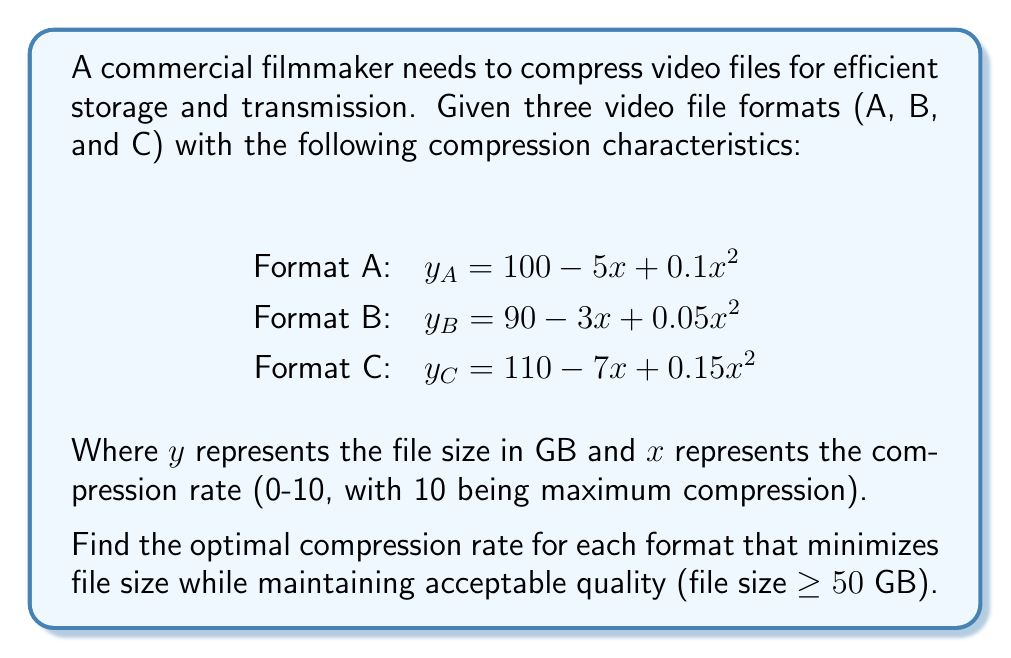Can you answer this question? To find the optimal compression rate for each format, we need to minimize $y$ (file size) while keeping it above or equal to 50 GB. We'll follow these steps for each format:

1. Find the minimum of the quadratic function by calculating its vertex.
2. Check if the minimum is above 50 GB. If not, find the point where $y = 50$.

For Format A: $y_A = 100 - 5x + 0.1x^2$

1. Vertex: $x = -b/(2a) = 5/(2(0.1)) = 25$
   This is outside our range (0-10), so the minimum will be at $x = 10$.

2. At $x = 10$: $y_A = 100 - 5(10) + 0.1(10^2) = 60$ GB
   This is above 50 GB, so $x = 10$ is optimal.

For Format B: $y_B = 90 - 3x + 0.05x^2$

1. Vertex: $x = 3/(2(0.05)) = 30$
   This is outside our range, so the minimum will be at $x = 10$.

2. At $x = 10$: $y_B = 90 - 3(10) + 0.05(10^2) = 65$ GB
   This is above 50 GB, so $x = 10$ is optimal.

For Format C: $y_C = 110 - 7x + 0.15x^2$

1. Vertex: $x = 7/(2(0.15)) = 23.33$
   This is outside our range, so the minimum will be at $x = 10$.

2. At $x = 10$: $y_C = 110 - 7(10) + 0.15(10^2) = 55$ GB
   This is above 50 GB, so $x = 10$ is optimal.

For all formats, the optimal compression rate is 10, which gives the smallest file size while maintaining acceptable quality.
Answer: 10 for all formats 